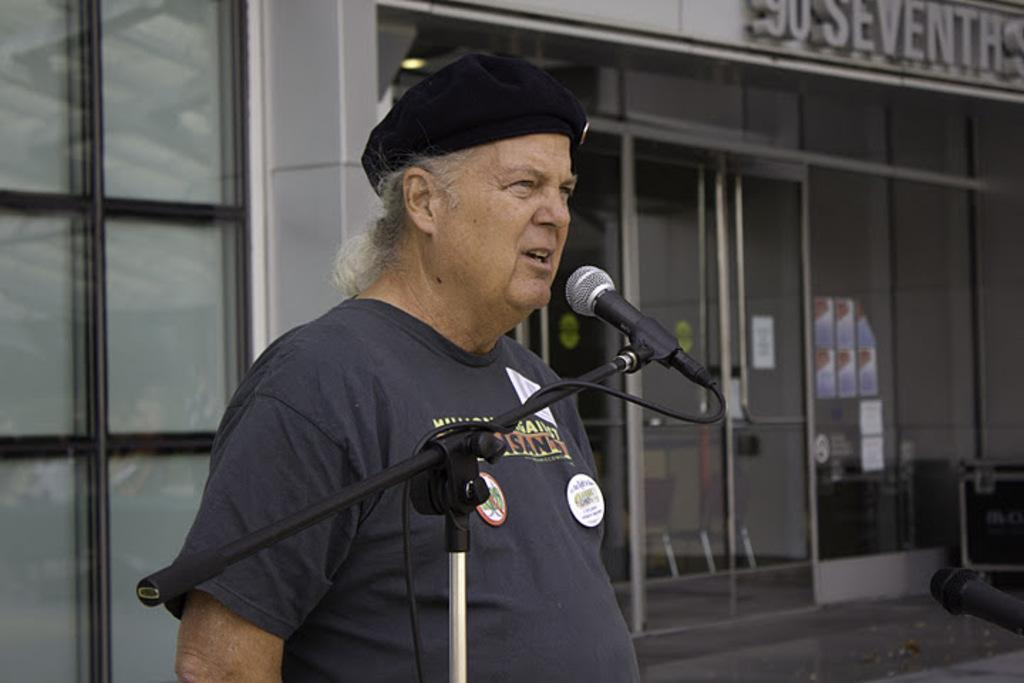What is the man in the image doing? The man is standing in front of a mic. What can be seen in the background of the image? There is a building, papers pasted on the wall, benches on the floor, and a name board in the background. How many hours does the earthquake last in the image? There is no earthquake present in the image, so it is not possible to determine its duration. What type of fiction is the man reading from the papers on the wall? The image does not show the man reading any fiction from the papers on the wall; he is standing in front of a mic. 